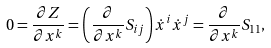Convert formula to latex. <formula><loc_0><loc_0><loc_500><loc_500>0 = \frac { \partial Z } { \partial x ^ { k } } = \left ( \frac { \partial } { \partial x ^ { k } } S _ { i j } \right ) \dot { x } ^ { i } \dot { x } ^ { j } = \frac { \partial } { \partial x ^ { k } } S _ { 1 1 } ,</formula> 